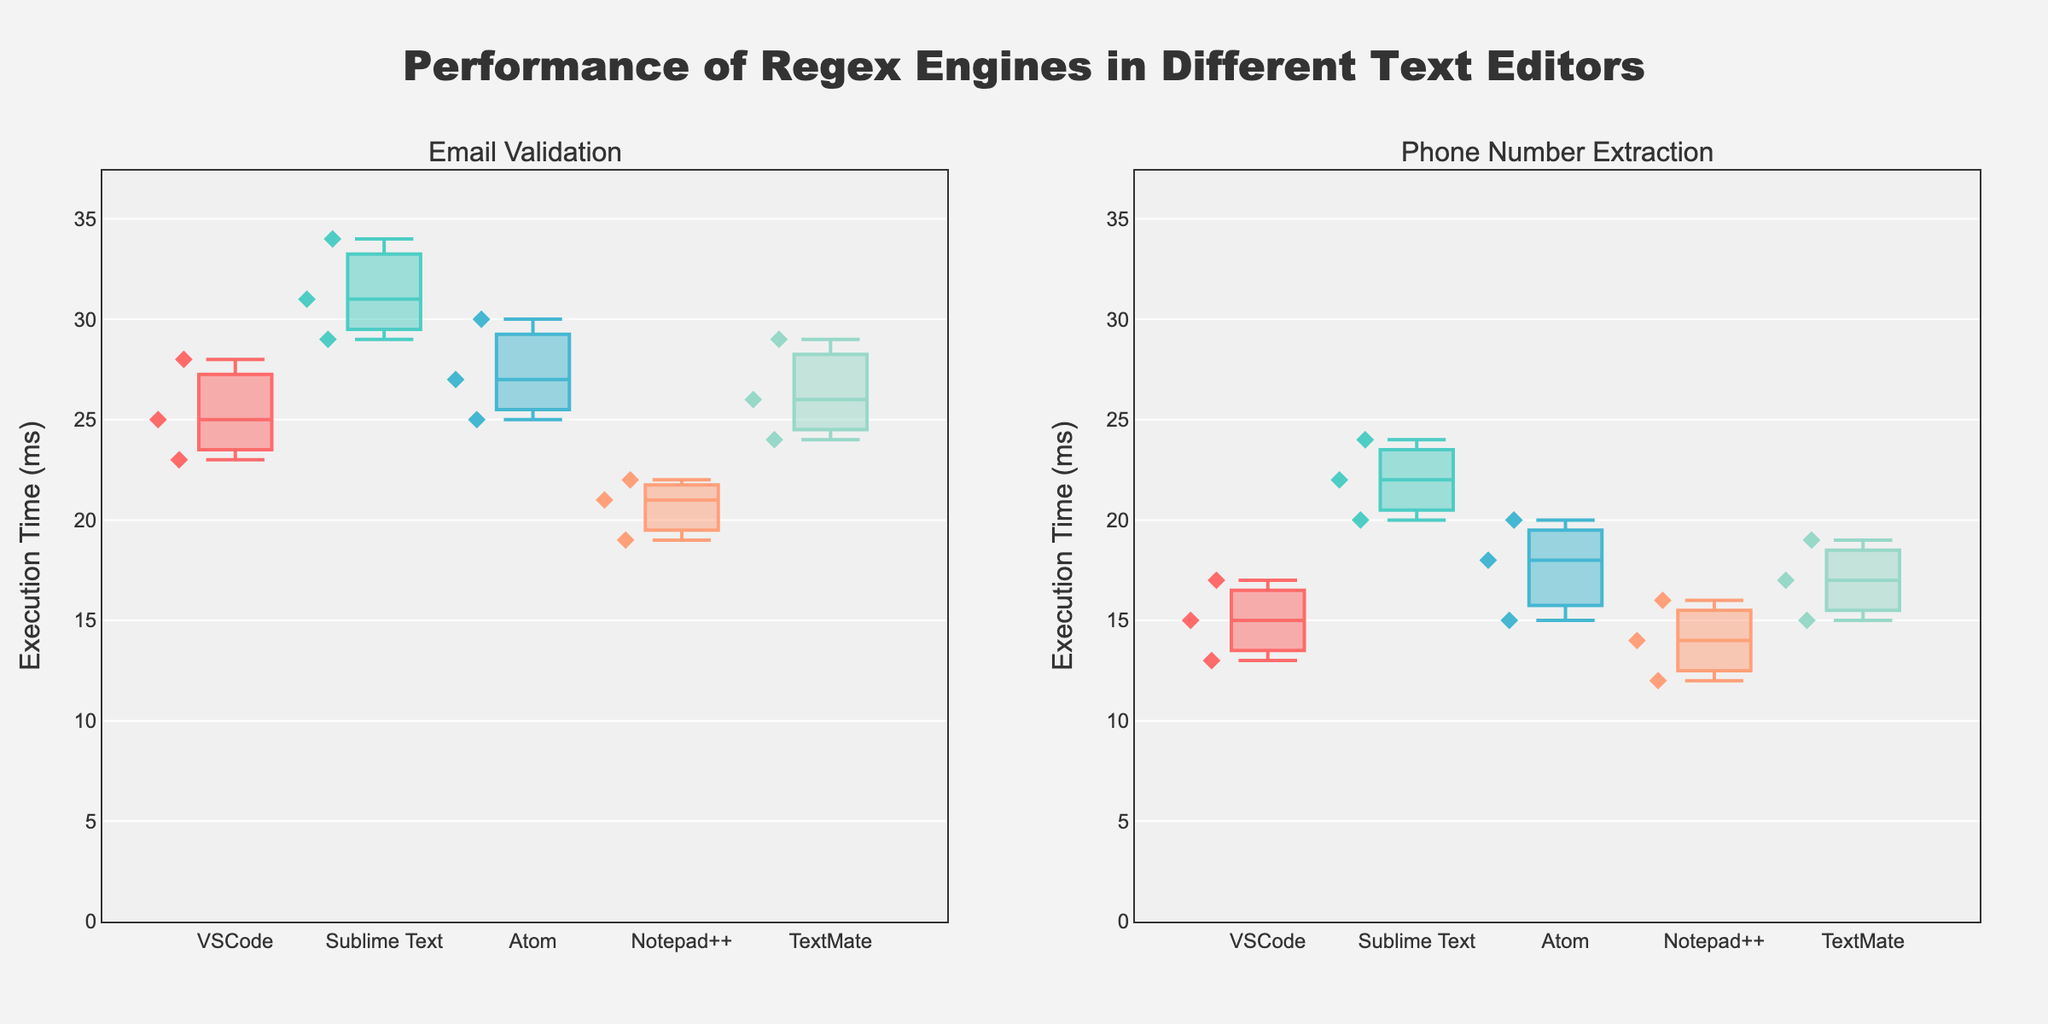How many editors are compared in the "Email Validation" plot? There are five different colors representing different editors in the "Email Validation" box plot. Each color corresponds to a different editor: VSCode, Sublime Text, Atom, Notepad++, and TextMate.
Answer: 5 Which editor has the highest median execution time for the "Phone Number Extraction" pattern? By visually inspecting the medians (the central lines in the boxes) for each editor in the "Phone Number Extraction" plot, Sublime Text has the highest median execution time compared to the other editors.
Answer: Sublime Text What's the range of execution times for Oniguruma in VSCode for the "Email Validation" pattern? Looking at the "Email Validation" box plot for VSCode, the whiskers extend from 23 ms to 28 ms, representing the range. Therefore, the range is 28 - 23 = 5 ms.
Answer: 5 ms Which pattern generally has lower execution times across all editors? By comparing the overall height of the box plots, the "Phone Number Extraction" pattern exhibits generally lower execution times than the "Email Validation" pattern, as the boxes and whiskers are positioned lower on the y-axis.
Answer: Phone Number Extraction Between TextMate and Atom, which editor shows more variability in execution time for the "Email Validation" pattern? Variability can be assessed by the range of values (distance between the top and bottom whiskers). In the "Email Validation" box plot, TextMate shows more variability than Atom, as its whiskers span a wider range.
Answer: TextMate What is the execution time for the slowest recorded "Email Validation" in Notepad++? For the "Email Validation" pattern in Notepad++, the highest point in the box plot represents the slowest execution time, which is at 22 ms.
Answer: 22 ms Are there any outliers in the execution times for the "Phone Number Extraction" pattern across any editors? There are no individual points outside the whiskers in the "Phone Number Extraction" box plots for any of the editors, indicating there are no outliers.
Answer: No Which regex engine appears in multiple editors for the "Email Validation" pattern? By observing the colors and editors in the "Email Validation" plot, Oniguruma appears in VSCode, Atom, and TextMate. This indicates it is used in multiple editors for "Email Validation".
Answer: Oniguruma What is the common format used by the box plots to represent the data points? Each box plot uses diamonds to represent individual data points, as indicated by the shape of the markers on each plot.
Answer: Diamond 